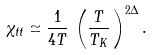Convert formula to latex. <formula><loc_0><loc_0><loc_500><loc_500>\chi _ { t t } \simeq \frac { 1 } { 4 T } \, \left ( \frac { T } { T _ { K } } \, \right ) ^ { 2 \Delta } .</formula> 